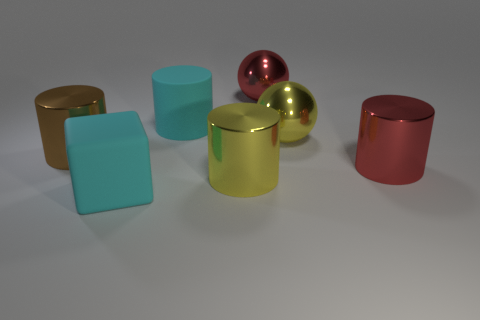How many things are large matte things or big yellow things to the right of the big yellow shiny cylinder?
Your answer should be compact. 3. There is a brown thing that is the same size as the rubber cylinder; what is it made of?
Give a very brief answer. Metal. Are the big brown thing and the cyan cylinder made of the same material?
Your response must be concise. No. What color is the thing that is both in front of the cyan rubber cylinder and behind the large brown cylinder?
Give a very brief answer. Yellow. Does the big rubber thing on the right side of the block have the same color as the block?
Offer a terse response. Yes. There is a brown metal object that is the same size as the yellow cylinder; what shape is it?
Provide a short and direct response. Cylinder. How many other objects are the same color as the rubber cylinder?
Your answer should be very brief. 1. What number of other things are there of the same material as the large yellow cylinder
Your answer should be compact. 4. What is the shape of the red metallic object that is in front of the big ball behind the cyan rubber object behind the red cylinder?
Your response must be concise. Cylinder. The large cyan object in front of the cyan thing behind the large brown thing is made of what material?
Provide a short and direct response. Rubber. 